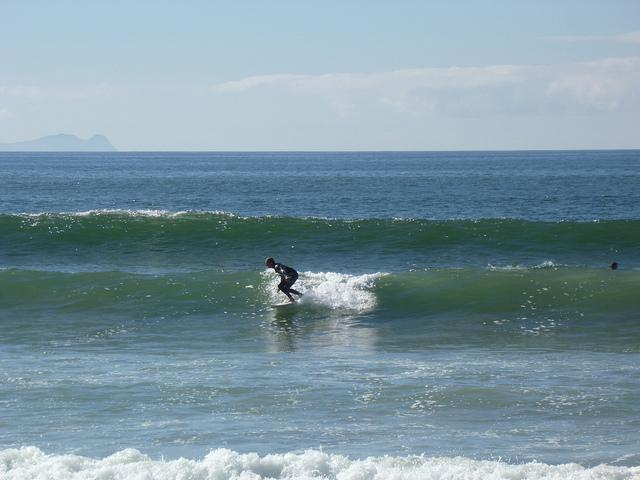What is a term related to this event?

Choices:
A) goal
B) homerun
C) surfs up
D) balance beam surfs up 